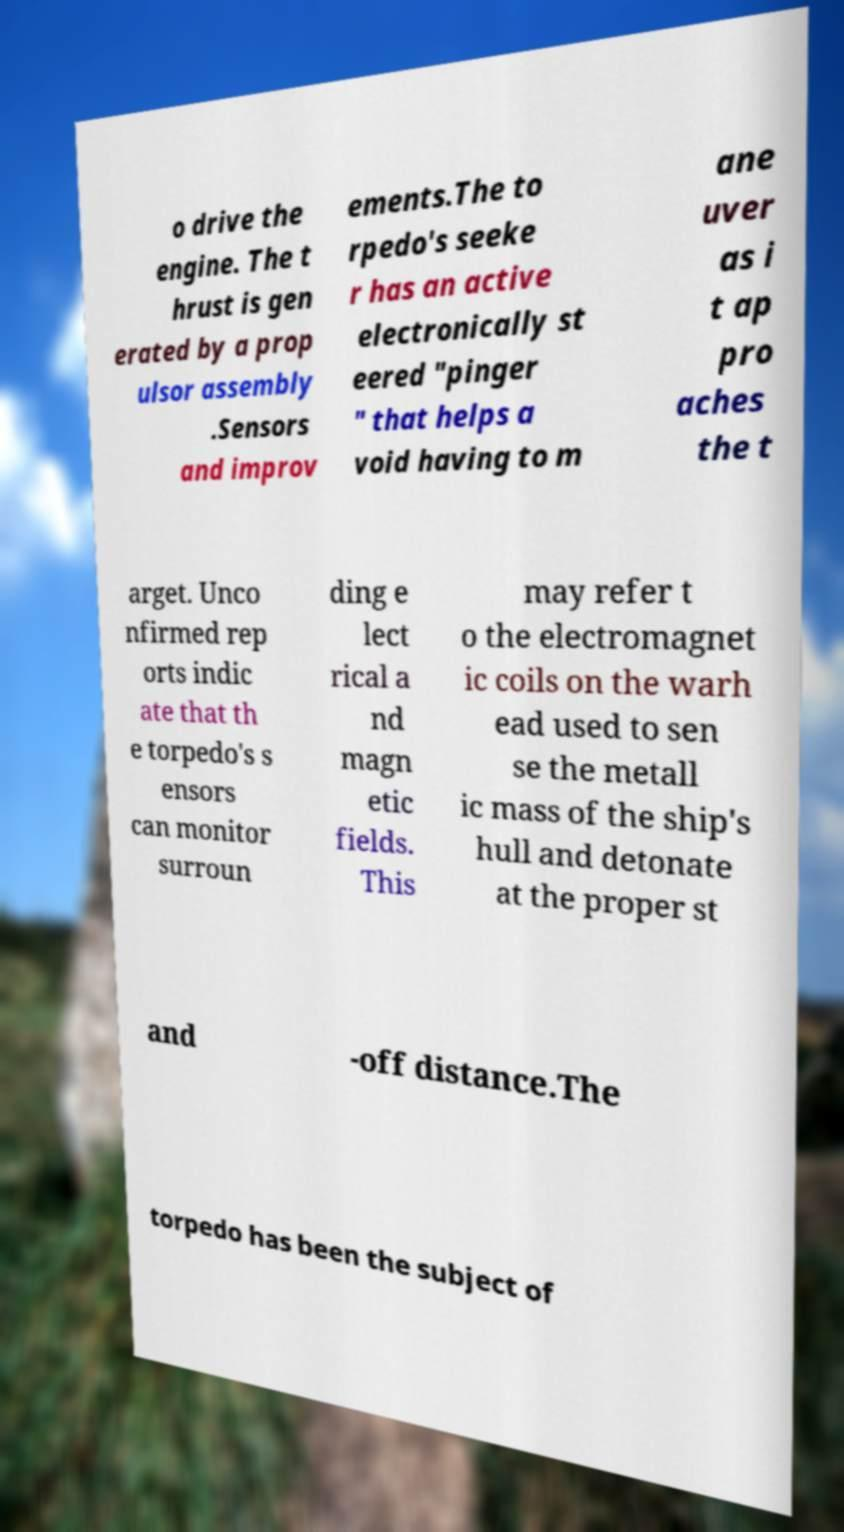There's text embedded in this image that I need extracted. Can you transcribe it verbatim? o drive the engine. The t hrust is gen erated by a prop ulsor assembly .Sensors and improv ements.The to rpedo's seeke r has an active electronically st eered "pinger " that helps a void having to m ane uver as i t ap pro aches the t arget. Unco nfirmed rep orts indic ate that th e torpedo's s ensors can monitor surroun ding e lect rical a nd magn etic fields. This may refer t o the electromagnet ic coils on the warh ead used to sen se the metall ic mass of the ship's hull and detonate at the proper st and -off distance.The torpedo has been the subject of 